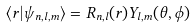Convert formula to latex. <formula><loc_0><loc_0><loc_500><loc_500>\langle { r } | \psi _ { n , l , m } \rangle = R _ { n , l } ( r ) Y _ { l , m } ( \theta , \phi )</formula> 